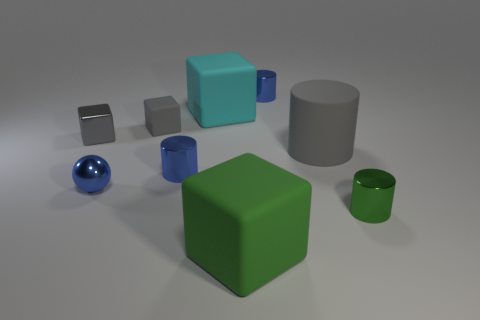Is there a pattern in how the objects are arranged on the surface? There doesn't seem to be a deliberate pattern to the arrangement of the objects. They are placed in a somewhat scattered manner across the surface without any apparent order or symmetry. Could the positioning of objects suggest any form of depth perception in this scene? Yes, the varying sizes and overlapping positions of the objects, such as the small spheres in front of larger cubes, create a sense of depth in the image. The perspective from which we're viewing the scene also contributes to this perception. 